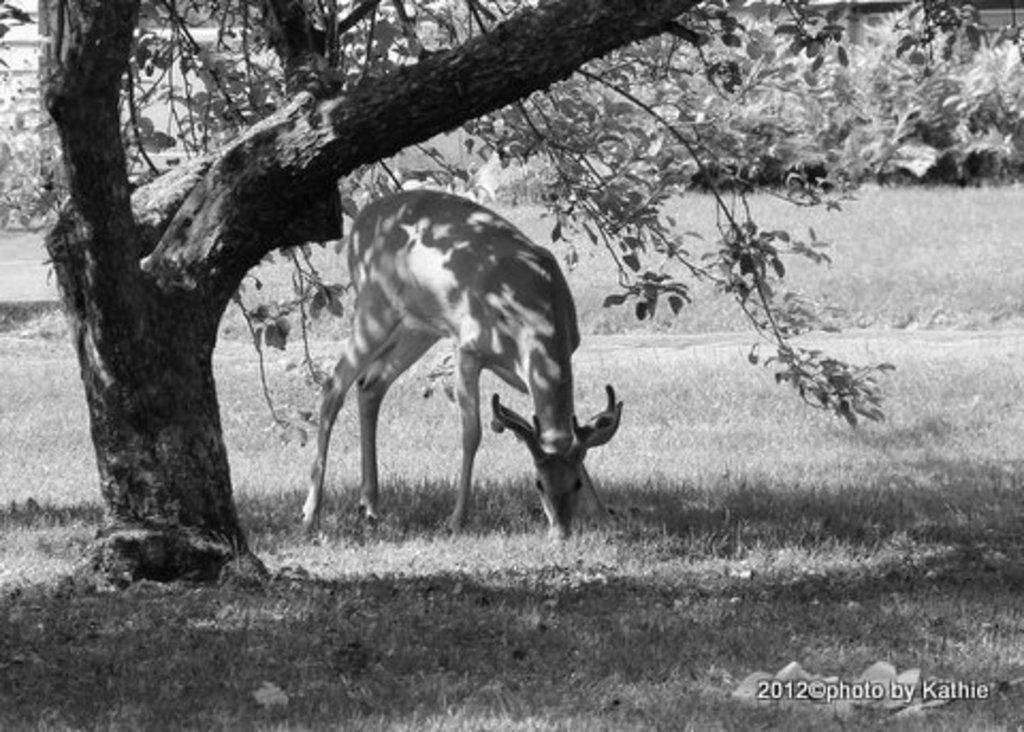Describe this image in one or two sentences. In this black and white image, we can see an animal under the tree. There is a grass on the ground. 